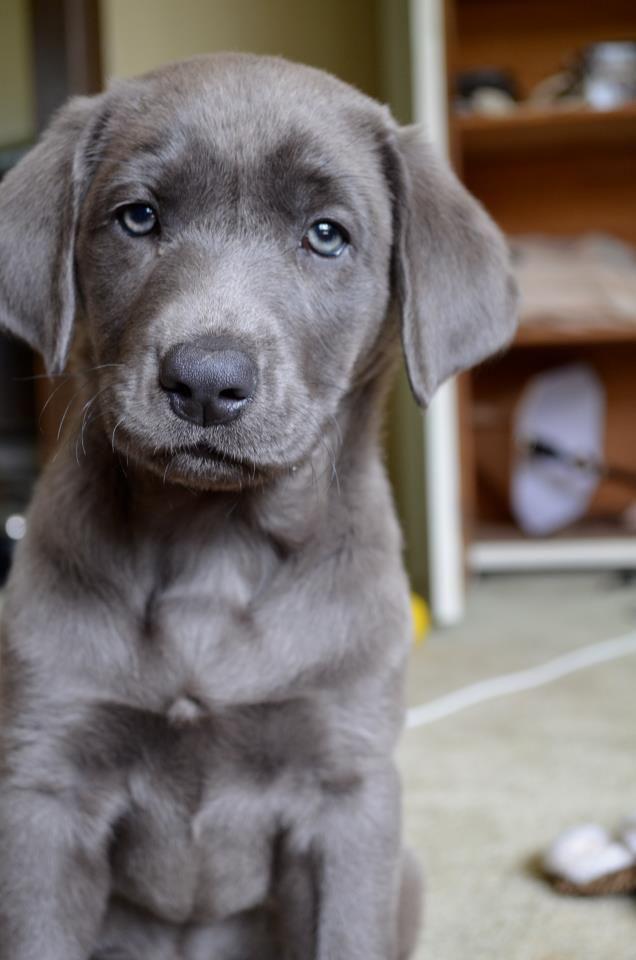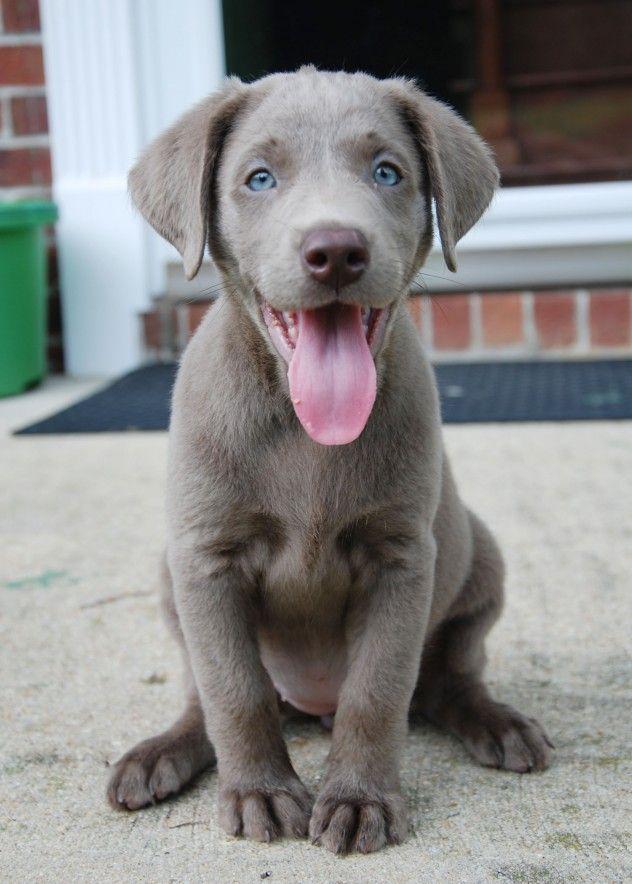The first image is the image on the left, the second image is the image on the right. Examine the images to the left and right. Is the description "The right image contains one dog with its tongue hanging out." accurate? Answer yes or no. Yes. The first image is the image on the left, the second image is the image on the right. For the images shown, is this caption "Each image contains exactly one dog, all dogs have grey fur, and one dog has its tongue hanging out." true? Answer yes or no. Yes. 